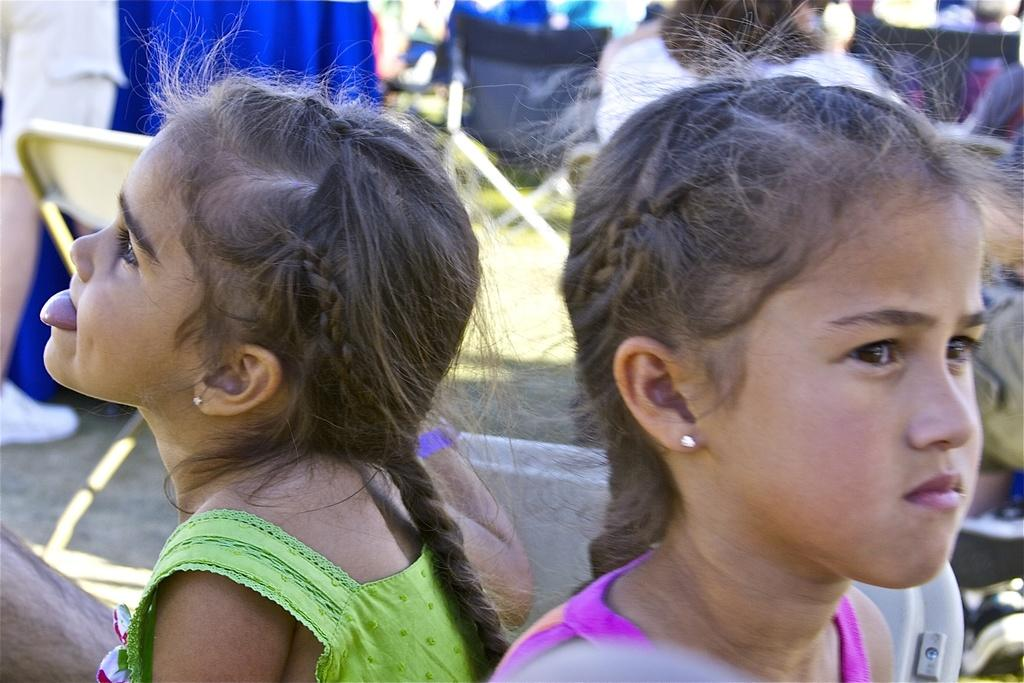How many girls are in the image? There are two girls in the image. What can be seen in the background of the image? Chairs are present on the ground in the background, and there are also a few persons visible. What type of door can be seen in the image? There is no door present in the image. What kind of pleasure are the girls experiencing in the image? The image does not provide any information about the girls' emotions or experiences, so it cannot be determined if they are experiencing pleasure. 